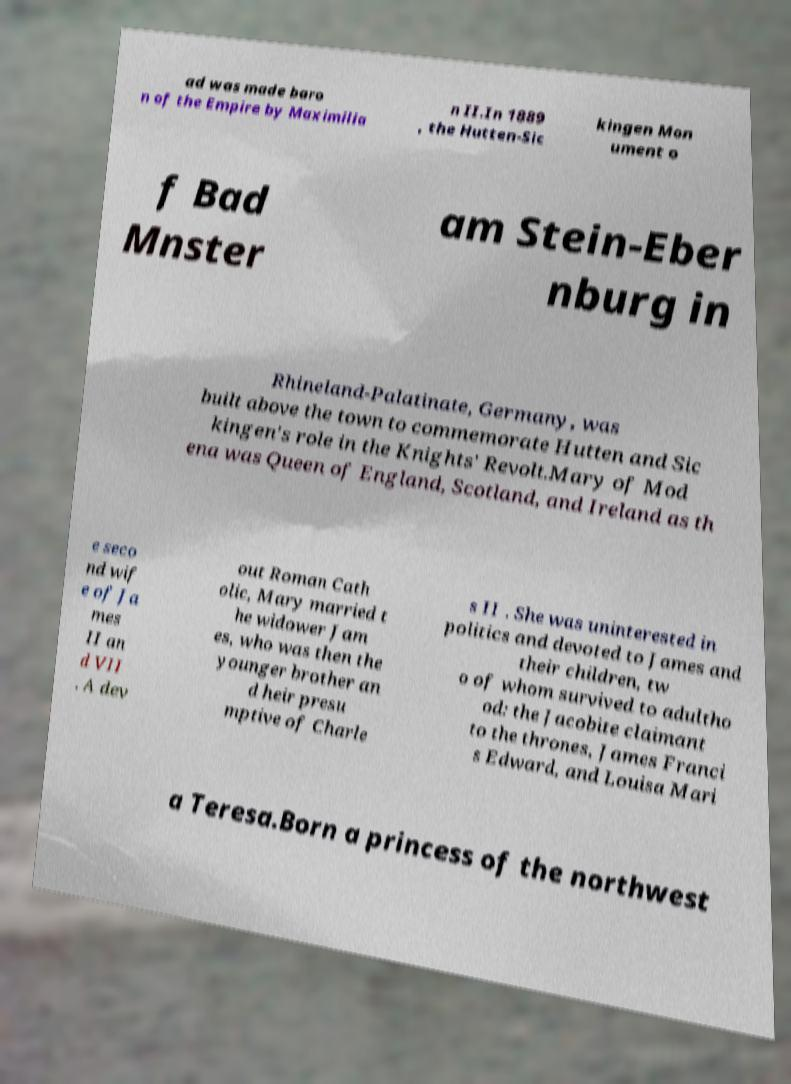There's text embedded in this image that I need extracted. Can you transcribe it verbatim? ad was made baro n of the Empire by Maximilia n II.In 1889 , the Hutten-Sic kingen Mon ument o f Bad Mnster am Stein-Eber nburg in Rhineland-Palatinate, Germany, was built above the town to commemorate Hutten and Sic kingen's role in the Knights' Revolt.Mary of Mod ena was Queen of England, Scotland, and Ireland as th e seco nd wif e of Ja mes II an d VII . A dev out Roman Cath olic, Mary married t he widower Jam es, who was then the younger brother an d heir presu mptive of Charle s II . She was uninterested in politics and devoted to James and their children, tw o of whom survived to adultho od: the Jacobite claimant to the thrones, James Franci s Edward, and Louisa Mari a Teresa.Born a princess of the northwest 